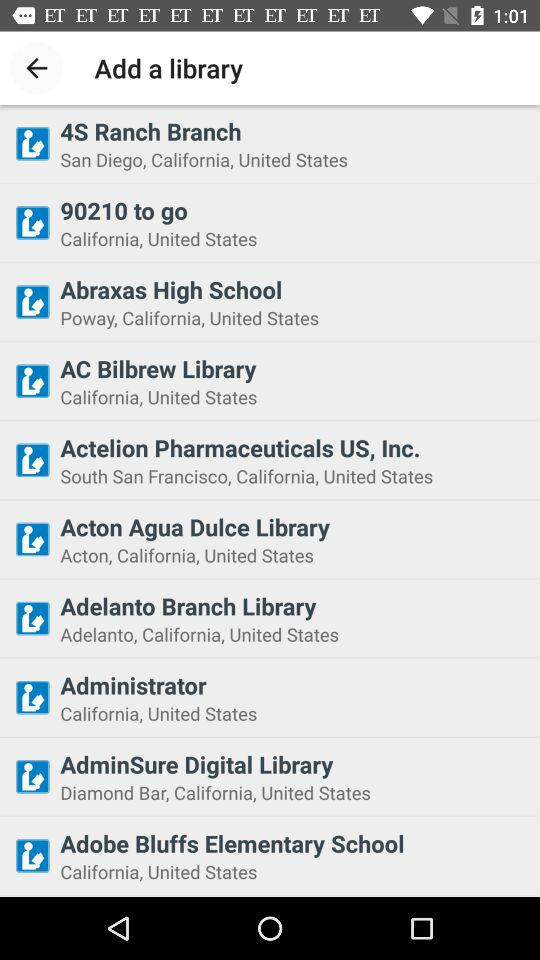Where is the "AC Bilbrew Library" located? The "AC Bilbrew Library" is located in California, United States. 